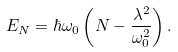<formula> <loc_0><loc_0><loc_500><loc_500>E _ { N } = \hbar { \omega } _ { 0 } \left ( N - \frac { \lambda ^ { 2 } } { \omega _ { 0 } ^ { 2 } } \right ) .</formula> 